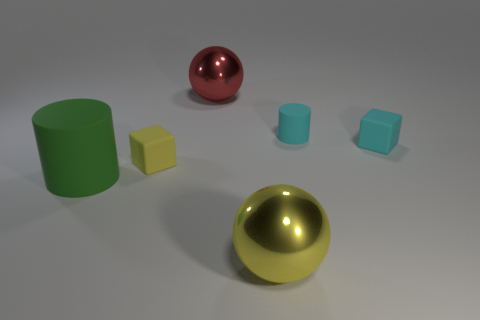How many yellow matte things are there?
Make the answer very short. 1. There is a small yellow object; does it have the same shape as the matte thing in front of the small yellow cube?
Offer a terse response. No. There is a yellow thing on the right side of the small yellow matte thing; what size is it?
Provide a short and direct response. Large. What is the green thing made of?
Your answer should be compact. Rubber. Does the shiny object behind the big green matte cylinder have the same shape as the large yellow thing?
Make the answer very short. Yes. What is the size of the thing that is the same color as the tiny cylinder?
Give a very brief answer. Small. Are there any yellow cylinders of the same size as the cyan block?
Your response must be concise. No. There is a rubber cylinder that is on the right side of the large metallic sphere on the left side of the large yellow object; is there a large green rubber object that is behind it?
Your response must be concise. No. Do the tiny rubber cylinder and the big ball on the right side of the red object have the same color?
Keep it short and to the point. No. The tiny thing to the right of the matte cylinder to the right of the rubber cube left of the big yellow thing is made of what material?
Ensure brevity in your answer.  Rubber. 